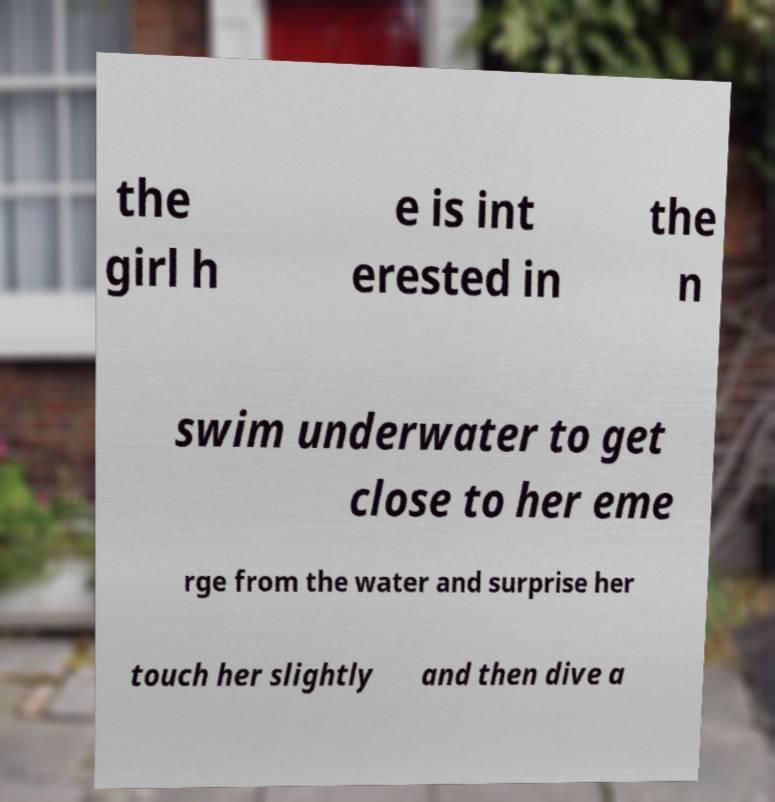For documentation purposes, I need the text within this image transcribed. Could you provide that? the girl h e is int erested in the n swim underwater to get close to her eme rge from the water and surprise her touch her slightly and then dive a 